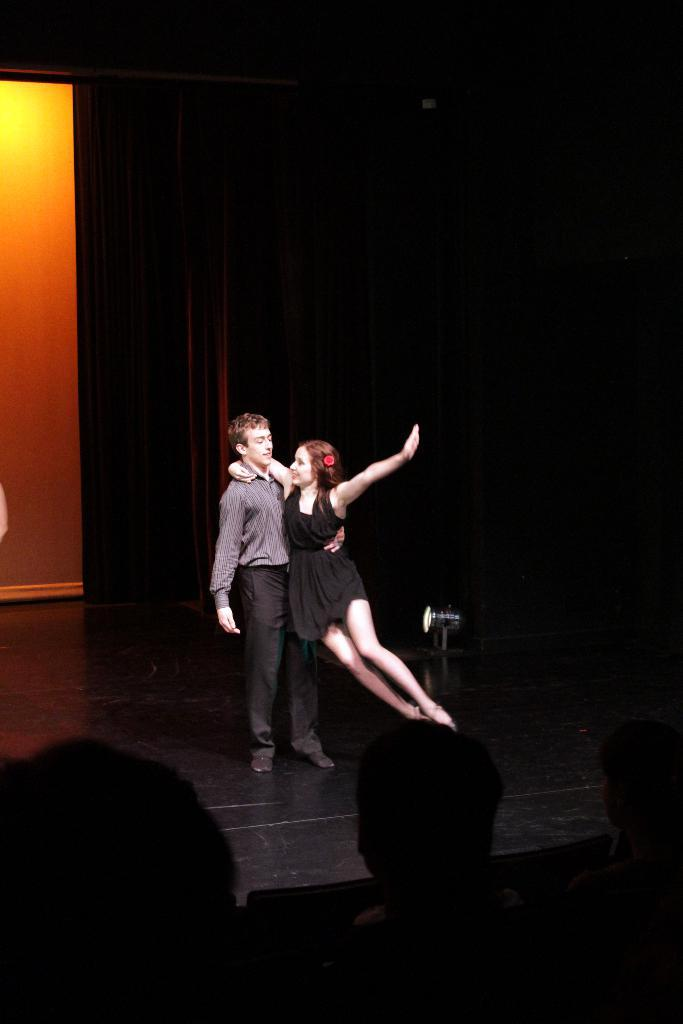How many people with black and grey color dresses are in the image? There are two people with black and grey color dresses in the image. What can be observed about the people in front of these two people? There are more people in front of these two people. What is the other prominent feature in the image? There is a banner in the image. What is the color of the background in the image? The background of the image is black. What type of apparel is the orange wearing in the image? There is no orange present in the image, as the background color is black. Can you describe the running style of the people in the image? There is no indication of running in the image; the people are standing or walking. 